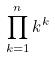Convert formula to latex. <formula><loc_0><loc_0><loc_500><loc_500>\prod _ { k = 1 } ^ { n } k ^ { k }</formula> 